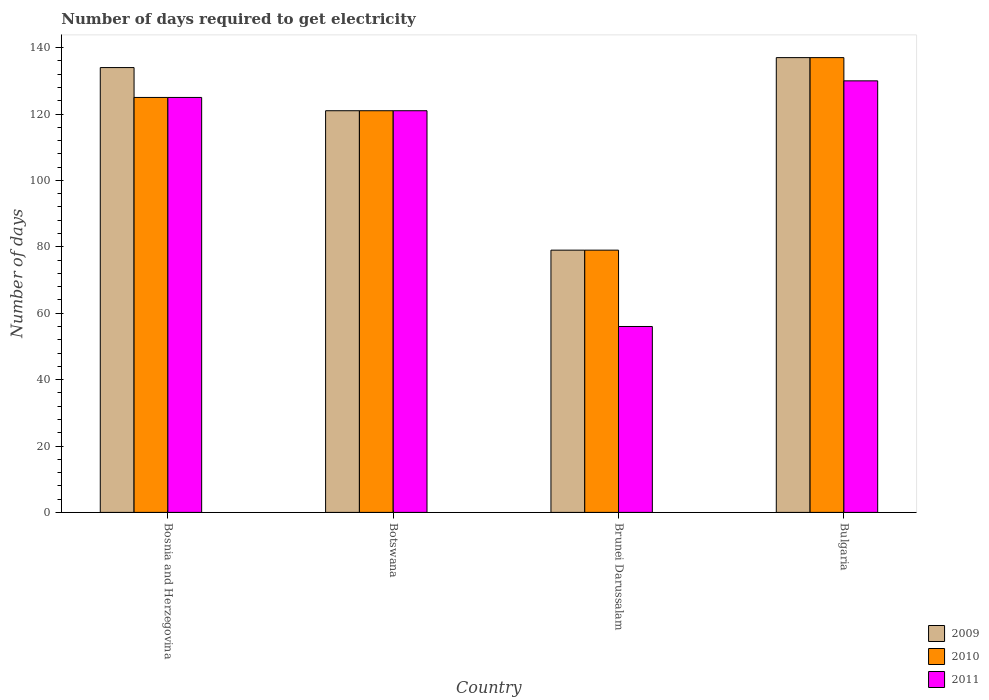Are the number of bars on each tick of the X-axis equal?
Give a very brief answer. Yes. What is the label of the 3rd group of bars from the left?
Your answer should be very brief. Brunei Darussalam. In how many cases, is the number of bars for a given country not equal to the number of legend labels?
Provide a succinct answer. 0. What is the number of days required to get electricity in in 2011 in Brunei Darussalam?
Your answer should be very brief. 56. Across all countries, what is the maximum number of days required to get electricity in in 2009?
Offer a very short reply. 137. Across all countries, what is the minimum number of days required to get electricity in in 2010?
Provide a short and direct response. 79. In which country was the number of days required to get electricity in in 2009 maximum?
Offer a very short reply. Bulgaria. In which country was the number of days required to get electricity in in 2009 minimum?
Provide a succinct answer. Brunei Darussalam. What is the total number of days required to get electricity in in 2009 in the graph?
Your answer should be very brief. 471. What is the average number of days required to get electricity in in 2009 per country?
Ensure brevity in your answer.  117.75. In how many countries, is the number of days required to get electricity in in 2011 greater than 60 days?
Your answer should be very brief. 3. What is the ratio of the number of days required to get electricity in in 2009 in Brunei Darussalam to that in Bulgaria?
Give a very brief answer. 0.58. What is the difference between the highest and the second highest number of days required to get electricity in in 2010?
Offer a terse response. 12. What is the difference between the highest and the lowest number of days required to get electricity in in 2010?
Offer a very short reply. 58. What does the 3rd bar from the left in Botswana represents?
Make the answer very short. 2011. What does the 2nd bar from the right in Botswana represents?
Offer a terse response. 2010. Is it the case that in every country, the sum of the number of days required to get electricity in in 2010 and number of days required to get electricity in in 2009 is greater than the number of days required to get electricity in in 2011?
Keep it short and to the point. Yes. How many countries are there in the graph?
Give a very brief answer. 4. What is the difference between two consecutive major ticks on the Y-axis?
Give a very brief answer. 20. Are the values on the major ticks of Y-axis written in scientific E-notation?
Offer a terse response. No. Where does the legend appear in the graph?
Your response must be concise. Bottom right. How many legend labels are there?
Offer a terse response. 3. What is the title of the graph?
Make the answer very short. Number of days required to get electricity. What is the label or title of the X-axis?
Give a very brief answer. Country. What is the label or title of the Y-axis?
Offer a terse response. Number of days. What is the Number of days in 2009 in Bosnia and Herzegovina?
Offer a very short reply. 134. What is the Number of days in 2010 in Bosnia and Herzegovina?
Keep it short and to the point. 125. What is the Number of days in 2011 in Bosnia and Herzegovina?
Offer a terse response. 125. What is the Number of days of 2009 in Botswana?
Offer a terse response. 121. What is the Number of days in 2010 in Botswana?
Your answer should be very brief. 121. What is the Number of days in 2011 in Botswana?
Provide a short and direct response. 121. What is the Number of days in 2009 in Brunei Darussalam?
Provide a succinct answer. 79. What is the Number of days of 2010 in Brunei Darussalam?
Your answer should be very brief. 79. What is the Number of days of 2009 in Bulgaria?
Make the answer very short. 137. What is the Number of days of 2010 in Bulgaria?
Your answer should be very brief. 137. What is the Number of days in 2011 in Bulgaria?
Your answer should be very brief. 130. Across all countries, what is the maximum Number of days of 2009?
Provide a succinct answer. 137. Across all countries, what is the maximum Number of days of 2010?
Your response must be concise. 137. Across all countries, what is the maximum Number of days of 2011?
Provide a succinct answer. 130. Across all countries, what is the minimum Number of days in 2009?
Your response must be concise. 79. Across all countries, what is the minimum Number of days of 2010?
Make the answer very short. 79. What is the total Number of days in 2009 in the graph?
Your answer should be very brief. 471. What is the total Number of days of 2010 in the graph?
Your answer should be compact. 462. What is the total Number of days of 2011 in the graph?
Provide a short and direct response. 432. What is the difference between the Number of days in 2010 in Bosnia and Herzegovina and that in Botswana?
Provide a short and direct response. 4. What is the difference between the Number of days in 2011 in Bosnia and Herzegovina and that in Botswana?
Ensure brevity in your answer.  4. What is the difference between the Number of days of 2009 in Bosnia and Herzegovina and that in Bulgaria?
Give a very brief answer. -3. What is the difference between the Number of days of 2010 in Bosnia and Herzegovina and that in Bulgaria?
Provide a short and direct response. -12. What is the difference between the Number of days in 2011 in Bosnia and Herzegovina and that in Bulgaria?
Make the answer very short. -5. What is the difference between the Number of days of 2009 in Botswana and that in Brunei Darussalam?
Make the answer very short. 42. What is the difference between the Number of days of 2011 in Botswana and that in Brunei Darussalam?
Keep it short and to the point. 65. What is the difference between the Number of days in 2009 in Botswana and that in Bulgaria?
Offer a terse response. -16. What is the difference between the Number of days of 2010 in Botswana and that in Bulgaria?
Your response must be concise. -16. What is the difference between the Number of days in 2011 in Botswana and that in Bulgaria?
Give a very brief answer. -9. What is the difference between the Number of days of 2009 in Brunei Darussalam and that in Bulgaria?
Keep it short and to the point. -58. What is the difference between the Number of days in 2010 in Brunei Darussalam and that in Bulgaria?
Your answer should be compact. -58. What is the difference between the Number of days of 2011 in Brunei Darussalam and that in Bulgaria?
Your response must be concise. -74. What is the difference between the Number of days of 2009 in Bosnia and Herzegovina and the Number of days of 2010 in Botswana?
Your answer should be very brief. 13. What is the difference between the Number of days in 2009 in Bosnia and Herzegovina and the Number of days in 2011 in Botswana?
Your response must be concise. 13. What is the difference between the Number of days in 2010 in Bosnia and Herzegovina and the Number of days in 2011 in Botswana?
Provide a succinct answer. 4. What is the difference between the Number of days of 2009 in Bosnia and Herzegovina and the Number of days of 2010 in Bulgaria?
Ensure brevity in your answer.  -3. What is the difference between the Number of days in 2010 in Bosnia and Herzegovina and the Number of days in 2011 in Bulgaria?
Keep it short and to the point. -5. What is the difference between the Number of days of 2009 in Botswana and the Number of days of 2010 in Brunei Darussalam?
Keep it short and to the point. 42. What is the difference between the Number of days of 2009 in Botswana and the Number of days of 2011 in Brunei Darussalam?
Provide a short and direct response. 65. What is the difference between the Number of days in 2010 in Botswana and the Number of days in 2011 in Brunei Darussalam?
Your response must be concise. 65. What is the difference between the Number of days in 2009 in Botswana and the Number of days in 2011 in Bulgaria?
Ensure brevity in your answer.  -9. What is the difference between the Number of days in 2009 in Brunei Darussalam and the Number of days in 2010 in Bulgaria?
Your response must be concise. -58. What is the difference between the Number of days in 2009 in Brunei Darussalam and the Number of days in 2011 in Bulgaria?
Keep it short and to the point. -51. What is the difference between the Number of days in 2010 in Brunei Darussalam and the Number of days in 2011 in Bulgaria?
Keep it short and to the point. -51. What is the average Number of days in 2009 per country?
Provide a succinct answer. 117.75. What is the average Number of days of 2010 per country?
Offer a very short reply. 115.5. What is the average Number of days of 2011 per country?
Keep it short and to the point. 108. What is the difference between the Number of days in 2009 and Number of days in 2010 in Bosnia and Herzegovina?
Provide a succinct answer. 9. What is the difference between the Number of days of 2010 and Number of days of 2011 in Bosnia and Herzegovina?
Your answer should be compact. 0. What is the difference between the Number of days in 2009 and Number of days in 2010 in Brunei Darussalam?
Make the answer very short. 0. What is the difference between the Number of days of 2009 and Number of days of 2011 in Brunei Darussalam?
Keep it short and to the point. 23. What is the difference between the Number of days in 2010 and Number of days in 2011 in Brunei Darussalam?
Keep it short and to the point. 23. What is the difference between the Number of days of 2009 and Number of days of 2010 in Bulgaria?
Provide a short and direct response. 0. What is the difference between the Number of days in 2010 and Number of days in 2011 in Bulgaria?
Ensure brevity in your answer.  7. What is the ratio of the Number of days of 2009 in Bosnia and Herzegovina to that in Botswana?
Your response must be concise. 1.11. What is the ratio of the Number of days in 2010 in Bosnia and Herzegovina to that in Botswana?
Your answer should be compact. 1.03. What is the ratio of the Number of days in 2011 in Bosnia and Herzegovina to that in Botswana?
Ensure brevity in your answer.  1.03. What is the ratio of the Number of days of 2009 in Bosnia and Herzegovina to that in Brunei Darussalam?
Your answer should be very brief. 1.7. What is the ratio of the Number of days of 2010 in Bosnia and Herzegovina to that in Brunei Darussalam?
Offer a very short reply. 1.58. What is the ratio of the Number of days in 2011 in Bosnia and Herzegovina to that in Brunei Darussalam?
Your answer should be compact. 2.23. What is the ratio of the Number of days in 2009 in Bosnia and Herzegovina to that in Bulgaria?
Provide a short and direct response. 0.98. What is the ratio of the Number of days in 2010 in Bosnia and Herzegovina to that in Bulgaria?
Give a very brief answer. 0.91. What is the ratio of the Number of days of 2011 in Bosnia and Herzegovina to that in Bulgaria?
Your response must be concise. 0.96. What is the ratio of the Number of days of 2009 in Botswana to that in Brunei Darussalam?
Keep it short and to the point. 1.53. What is the ratio of the Number of days of 2010 in Botswana to that in Brunei Darussalam?
Offer a very short reply. 1.53. What is the ratio of the Number of days in 2011 in Botswana to that in Brunei Darussalam?
Your answer should be compact. 2.16. What is the ratio of the Number of days in 2009 in Botswana to that in Bulgaria?
Provide a succinct answer. 0.88. What is the ratio of the Number of days in 2010 in Botswana to that in Bulgaria?
Offer a terse response. 0.88. What is the ratio of the Number of days in 2011 in Botswana to that in Bulgaria?
Keep it short and to the point. 0.93. What is the ratio of the Number of days in 2009 in Brunei Darussalam to that in Bulgaria?
Give a very brief answer. 0.58. What is the ratio of the Number of days in 2010 in Brunei Darussalam to that in Bulgaria?
Provide a short and direct response. 0.58. What is the ratio of the Number of days of 2011 in Brunei Darussalam to that in Bulgaria?
Provide a succinct answer. 0.43. What is the difference between the highest and the second highest Number of days of 2009?
Give a very brief answer. 3. What is the difference between the highest and the second highest Number of days of 2010?
Provide a succinct answer. 12. 